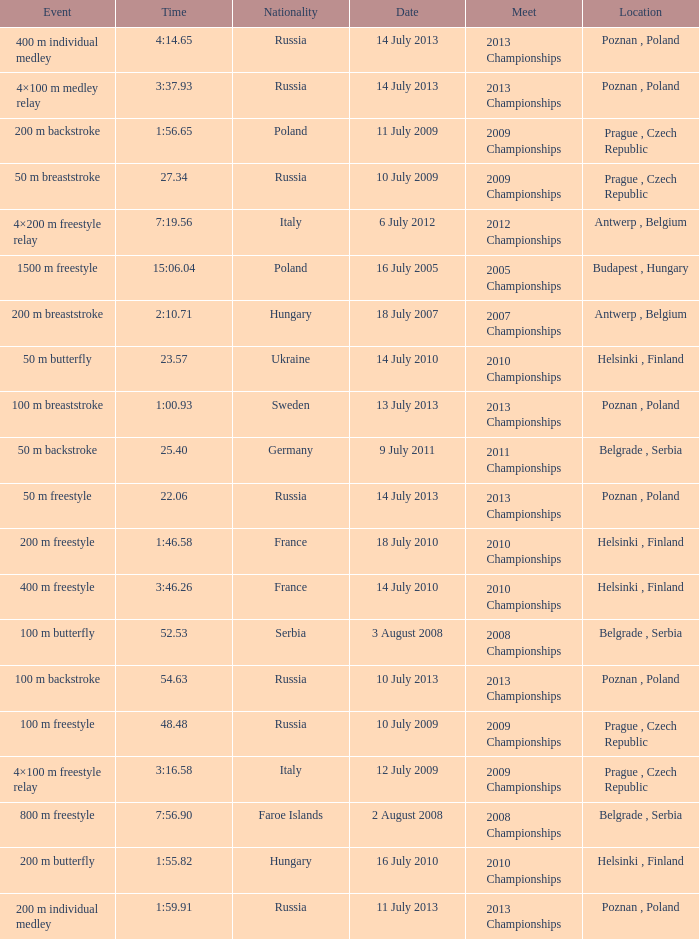Could you parse the entire table? {'header': ['Event', 'Time', 'Nationality', 'Date', 'Meet', 'Location'], 'rows': [['400 m individual medley', '4:14.65', 'Russia', '14 July 2013', '2013 Championships', 'Poznan , Poland'], ['4×100 m medley relay', '3:37.93', 'Russia', '14 July 2013', '2013 Championships', 'Poznan , Poland'], ['200 m backstroke', '1:56.65', 'Poland', '11 July 2009', '2009 Championships', 'Prague , Czech Republic'], ['50 m breaststroke', '27.34', 'Russia', '10 July 2009', '2009 Championships', 'Prague , Czech Republic'], ['4×200 m freestyle relay', '7:19.56', 'Italy', '6 July 2012', '2012 Championships', 'Antwerp , Belgium'], ['1500 m freestyle', '15:06.04', 'Poland', '16 July 2005', '2005 Championships', 'Budapest , Hungary'], ['200 m breaststroke', '2:10.71', 'Hungary', '18 July 2007', '2007 Championships', 'Antwerp , Belgium'], ['50 m butterfly', '23.57', 'Ukraine', '14 July 2010', '2010 Championships', 'Helsinki , Finland'], ['100 m breaststroke', '1:00.93', 'Sweden', '13 July 2013', '2013 Championships', 'Poznan , Poland'], ['50 m backstroke', '25.40', 'Germany', '9 July 2011', '2011 Championships', 'Belgrade , Serbia'], ['50 m freestyle', '22.06', 'Russia', '14 July 2013', '2013 Championships', 'Poznan , Poland'], ['200 m freestyle', '1:46.58', 'France', '18 July 2010', '2010 Championships', 'Helsinki , Finland'], ['400 m freestyle', '3:46.26', 'France', '14 July 2010', '2010 Championships', 'Helsinki , Finland'], ['100 m butterfly', '52.53', 'Serbia', '3 August 2008', '2008 Championships', 'Belgrade , Serbia'], ['100 m backstroke', '54.63', 'Russia', '10 July 2013', '2013 Championships', 'Poznan , Poland'], ['100 m freestyle', '48.48', 'Russia', '10 July 2009', '2009 Championships', 'Prague , Czech Republic'], ['4×100 m freestyle relay', '3:16.58', 'Italy', '12 July 2009', '2009 Championships', 'Prague , Czech Republic'], ['800 m freestyle', '7:56.90', 'Faroe Islands', '2 August 2008', '2008 Championships', 'Belgrade , Serbia'], ['200 m butterfly', '1:55.82', 'Hungary', '16 July 2010', '2010 Championships', 'Helsinki , Finland'], ['200 m individual medley', '1:59.91', 'Russia', '11 July 2013', '2013 Championships', 'Poznan , Poland']]} Where were the 2008 championships with a time of 7:56.90 held? Belgrade , Serbia. 